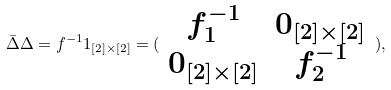<formula> <loc_0><loc_0><loc_500><loc_500>\bar { \Delta } \Delta = f ^ { - 1 } 1 _ { [ 2 ] \times [ 2 ] } = ( \begin{array} { c c } f _ { 1 } ^ { - 1 } & 0 _ { [ 2 ] \times [ 2 ] } \\ 0 _ { [ 2 ] \times [ 2 ] } & f _ { 2 } ^ { - 1 } \end{array} ) ,</formula> 